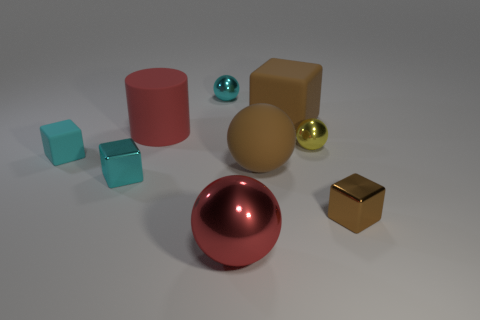Subtract all purple cubes. Subtract all gray cylinders. How many cubes are left? 4 Add 1 large rubber cubes. How many objects exist? 10 Subtract all balls. How many objects are left? 5 Add 4 cyan metallic blocks. How many cyan metallic blocks exist? 5 Subtract 1 cyan balls. How many objects are left? 8 Subtract all small yellow spheres. Subtract all big brown rubber things. How many objects are left? 6 Add 6 balls. How many balls are left? 10 